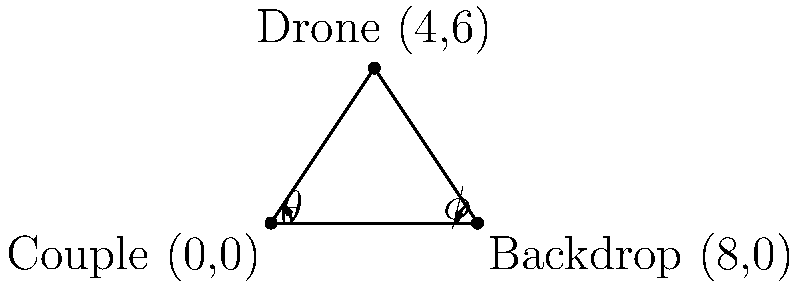A wedding photographer wants to use a drone to capture both the couple and a scenic backdrop in one frame. The couple is standing at point (0,0), and the backdrop is located at (8,0) on a coordinate plane. The photographer positions the drone at point (4,6) to capture both in the frame. Calculate:

a) The distance between the drone and the couple
b) The angle $\theta$ between the ground and the line from the couple to the drone
c) The angle $\phi$ between the ground and the line from the backdrop to the drone

Round your answers to two decimal places. Let's solve this step by step:

a) To find the distance between the drone and the couple:
   - The drone is at (4,6) and the couple is at (0,0)
   - Use the distance formula: $d = \sqrt{(x_2-x_1)^2 + (y_2-y_1)^2}$
   - $d = \sqrt{(4-0)^2 + (6-0)^2} = \sqrt{16 + 36} = \sqrt{52} = 7.21$ units

b) To find angle $\theta$:
   - We can use the arctangent function
   - $\theta = \arctan(\frac{\text{opposite}}{\text{adjacent}}) = \arctan(\frac{6}{4})$
   - $\theta = \arctan(1.5) = 0.9828$ radians
   - Converting to degrees: $0.9828 \times \frac{180}{\pi} = 56.31°$

c) To find angle $\phi$:
   - The backdrop is at (8,0), so we need to adjust our calculation
   - $\phi = \arctan(\frac{\text{opposite}}{\text{adjacent}}) = \arctan(\frac{6}{4})$
   - This is the same as $\theta$, so $\phi = 56.31°$
Answer: a) 7.21 units
b) 56.31°
c) 56.31° 